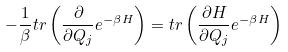<formula> <loc_0><loc_0><loc_500><loc_500>- \frac { 1 } { \beta } t r \left ( \frac { \partial } { \partial Q _ { j } } e ^ { - \beta H } \right ) = t r \left ( \frac { \partial H } { \partial Q _ { j } } e ^ { - \beta H } \right )</formula> 